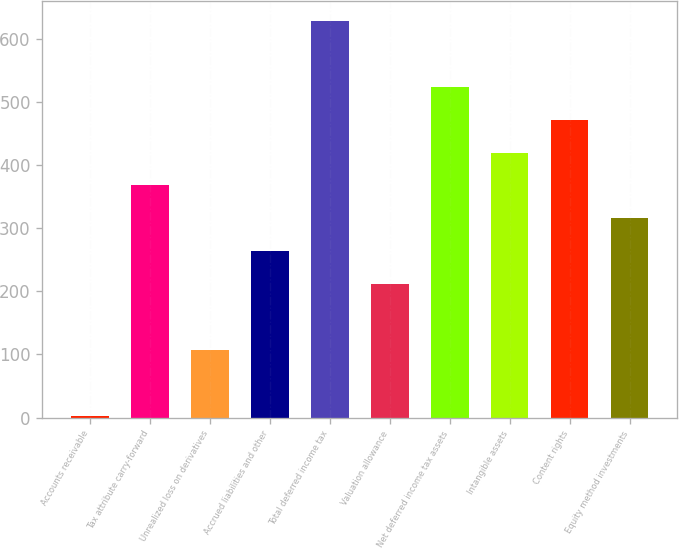<chart> <loc_0><loc_0><loc_500><loc_500><bar_chart><fcel>Accounts receivable<fcel>Tax attribute carry-forward<fcel>Unrealized loss on derivatives<fcel>Accrued liabilities and other<fcel>Total deferred income tax<fcel>Valuation allowance<fcel>Net deferred income tax assets<fcel>Intangible assets<fcel>Content rights<fcel>Equity method investments<nl><fcel>2<fcel>367.4<fcel>106.4<fcel>263<fcel>628.4<fcel>210.8<fcel>524<fcel>419.6<fcel>471.8<fcel>315.2<nl></chart> 